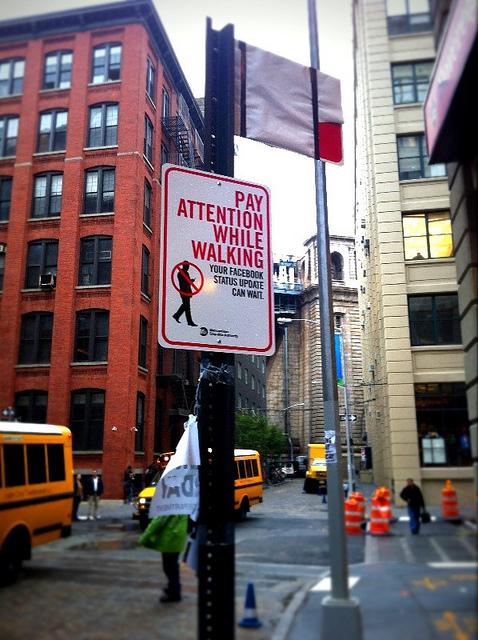What is the color of the building on the left?
Write a very short answer. Red. Is this a secure neighborhood?
Write a very short answer. No. Whom is this sign criticizing?
Keep it brief. Pedestrians. What does the sign tell people to do?
Give a very brief answer. Pay attention while walking. What is the price for diesel?
Short answer required. Not listed. Does this appear to be a noisy environment?
Quick response, please. Yes. Is it raining?
Concise answer only. No. Is it OK to cross the road diagonally?
Give a very brief answer. No. What is written on the sign?
Be succinct. Pay attention while walking. How many street signs are there?
Keep it brief. 1. 